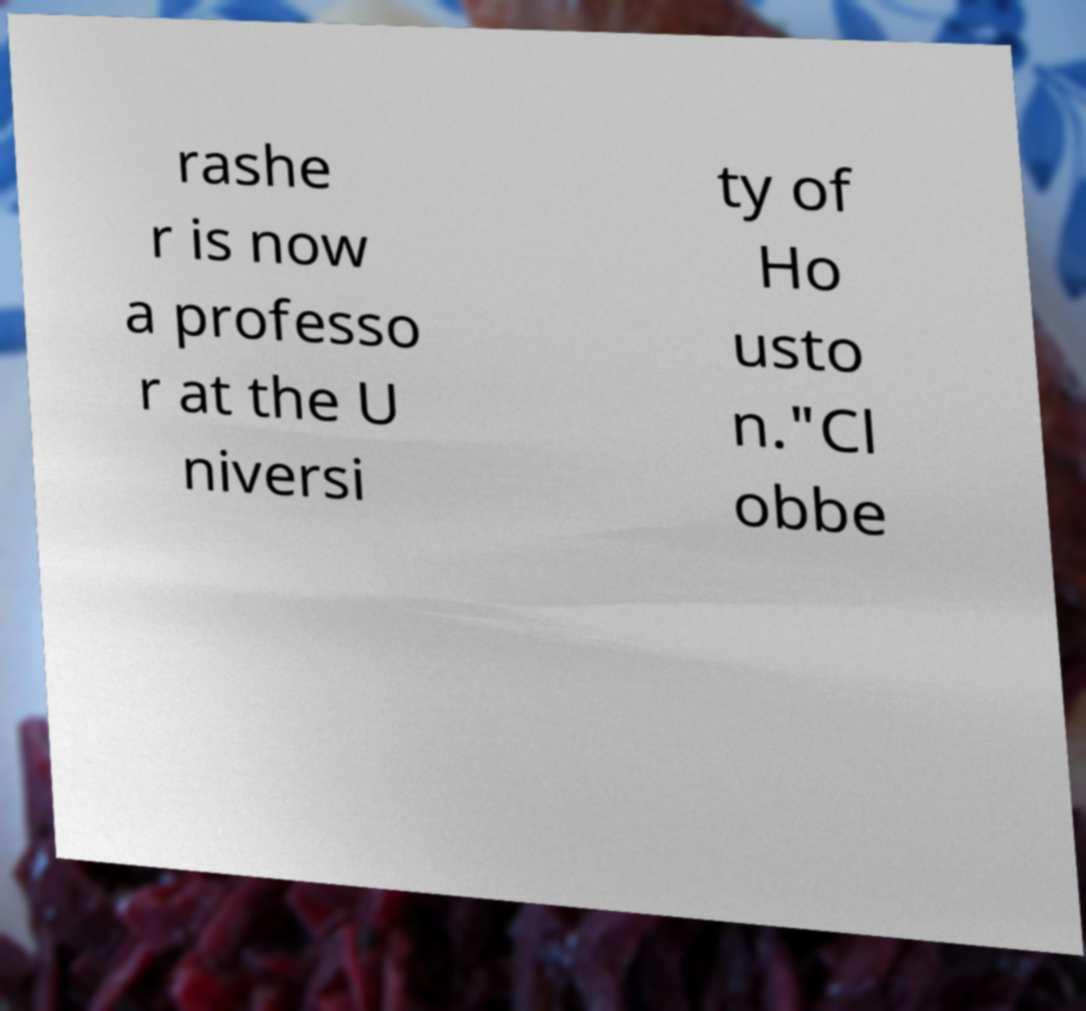Can you read and provide the text displayed in the image?This photo seems to have some interesting text. Can you extract and type it out for me? rashe r is now a professo r at the U niversi ty of Ho usto n."Cl obbe 